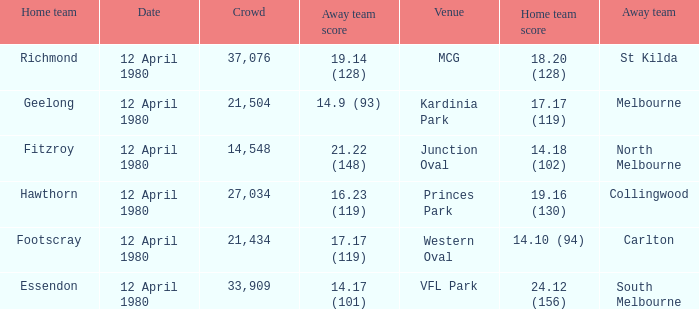Where did Essendon play as the home team? VFL Park. 